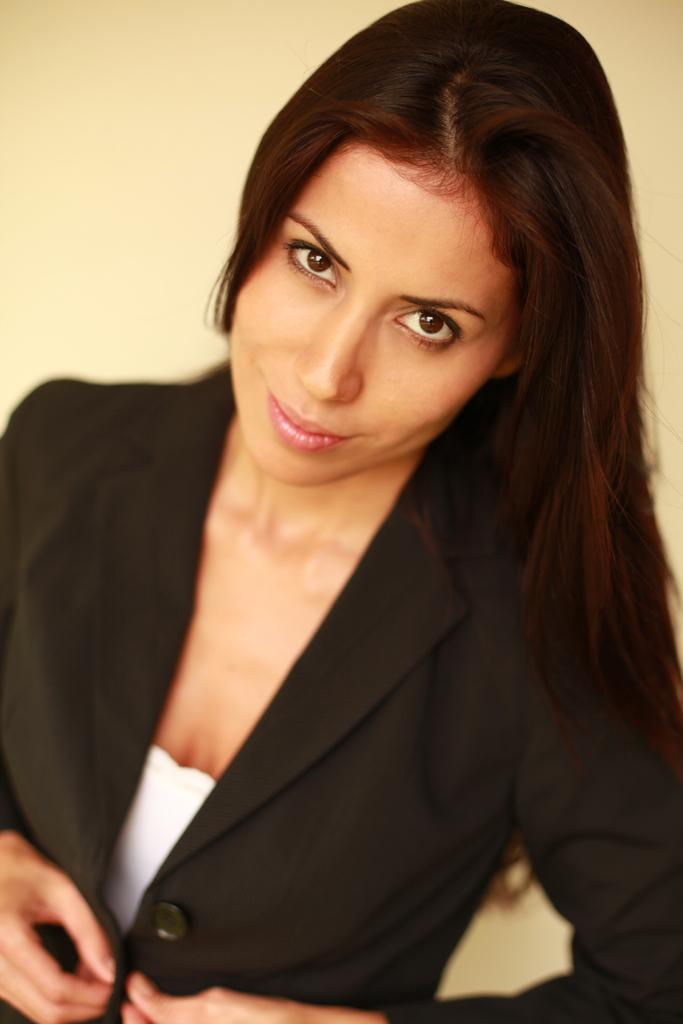Who is present in the image? There is a woman in the image. What is the woman wearing in the image? The woman is wearing a black color blazer. Where can the kettle be found in the image? There is no kettle present in the image. Are there any giants visible in the image? There are no giants visible in the image. 